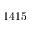<formula> <loc_0><loc_0><loc_500><loc_500>1 4 1 5</formula> 